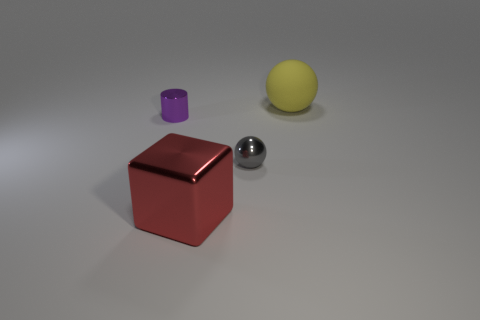Subtract all red balls. Subtract all gray cylinders. How many balls are left? 2 Add 3 small yellow cubes. How many objects exist? 7 Subtract all cubes. How many objects are left? 3 Subtract 0 green balls. How many objects are left? 4 Subtract all tiny brown matte objects. Subtract all spheres. How many objects are left? 2 Add 3 big shiny cubes. How many big shiny cubes are left? 4 Add 4 purple metal cylinders. How many purple metal cylinders exist? 5 